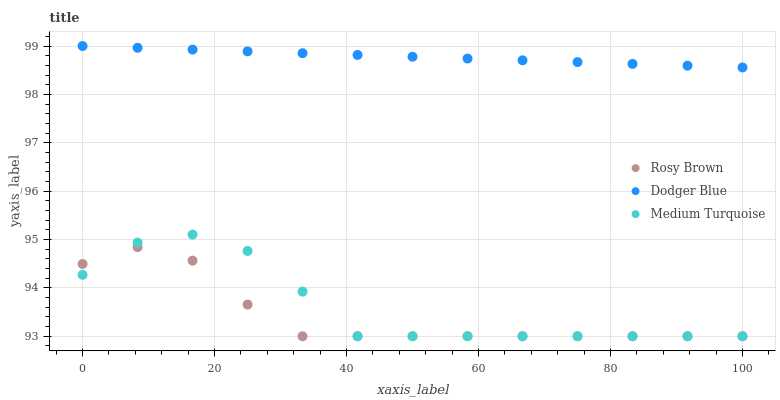Does Rosy Brown have the minimum area under the curve?
Answer yes or no. Yes. Does Dodger Blue have the maximum area under the curve?
Answer yes or no. Yes. Does Medium Turquoise have the minimum area under the curve?
Answer yes or no. No. Does Medium Turquoise have the maximum area under the curve?
Answer yes or no. No. Is Dodger Blue the smoothest?
Answer yes or no. Yes. Is Medium Turquoise the roughest?
Answer yes or no. Yes. Is Medium Turquoise the smoothest?
Answer yes or no. No. Is Dodger Blue the roughest?
Answer yes or no. No. Does Rosy Brown have the lowest value?
Answer yes or no. Yes. Does Dodger Blue have the lowest value?
Answer yes or no. No. Does Dodger Blue have the highest value?
Answer yes or no. Yes. Does Medium Turquoise have the highest value?
Answer yes or no. No. Is Rosy Brown less than Dodger Blue?
Answer yes or no. Yes. Is Dodger Blue greater than Medium Turquoise?
Answer yes or no. Yes. Does Rosy Brown intersect Medium Turquoise?
Answer yes or no. Yes. Is Rosy Brown less than Medium Turquoise?
Answer yes or no. No. Is Rosy Brown greater than Medium Turquoise?
Answer yes or no. No. Does Rosy Brown intersect Dodger Blue?
Answer yes or no. No. 